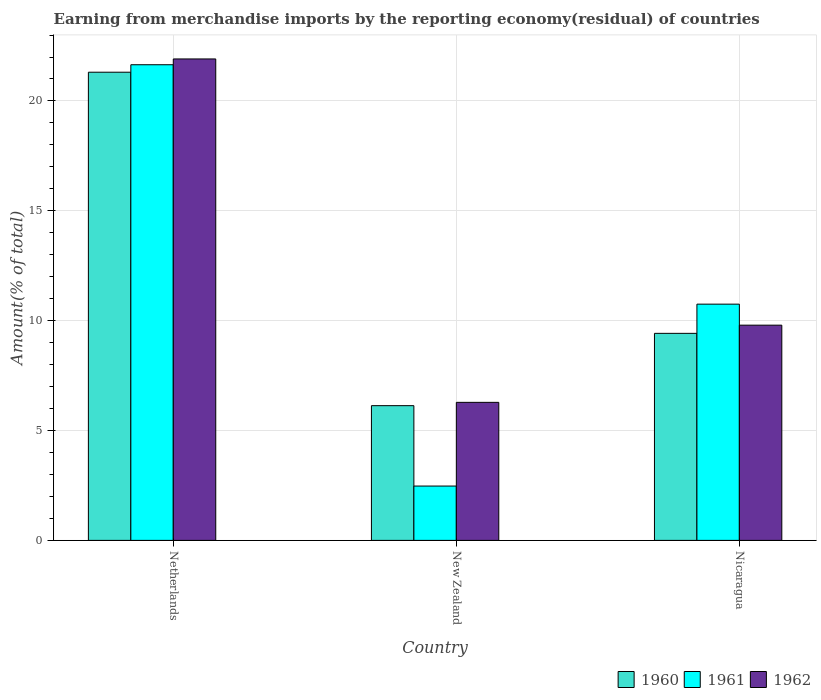How many different coloured bars are there?
Offer a very short reply. 3. How many groups of bars are there?
Your answer should be very brief. 3. Are the number of bars per tick equal to the number of legend labels?
Keep it short and to the point. Yes. What is the percentage of amount earned from merchandise imports in 1962 in Nicaragua?
Provide a short and direct response. 9.8. Across all countries, what is the maximum percentage of amount earned from merchandise imports in 1960?
Your answer should be very brief. 21.31. Across all countries, what is the minimum percentage of amount earned from merchandise imports in 1960?
Keep it short and to the point. 6.13. In which country was the percentage of amount earned from merchandise imports in 1962 maximum?
Your answer should be compact. Netherlands. In which country was the percentage of amount earned from merchandise imports in 1961 minimum?
Offer a terse response. New Zealand. What is the total percentage of amount earned from merchandise imports in 1961 in the graph?
Ensure brevity in your answer.  34.87. What is the difference between the percentage of amount earned from merchandise imports in 1962 in Netherlands and that in New Zealand?
Ensure brevity in your answer.  15.63. What is the difference between the percentage of amount earned from merchandise imports in 1962 in Netherlands and the percentage of amount earned from merchandise imports in 1960 in New Zealand?
Your response must be concise. 15.78. What is the average percentage of amount earned from merchandise imports in 1961 per country?
Provide a short and direct response. 11.62. What is the difference between the percentage of amount earned from merchandise imports of/in 1961 and percentage of amount earned from merchandise imports of/in 1960 in Netherlands?
Make the answer very short. 0.34. In how many countries, is the percentage of amount earned from merchandise imports in 1961 greater than 2 %?
Ensure brevity in your answer.  3. What is the ratio of the percentage of amount earned from merchandise imports in 1962 in Netherlands to that in Nicaragua?
Make the answer very short. 2.24. Is the difference between the percentage of amount earned from merchandise imports in 1961 in Netherlands and New Zealand greater than the difference between the percentage of amount earned from merchandise imports in 1960 in Netherlands and New Zealand?
Make the answer very short. Yes. What is the difference between the highest and the second highest percentage of amount earned from merchandise imports in 1962?
Make the answer very short. -12.12. What is the difference between the highest and the lowest percentage of amount earned from merchandise imports in 1961?
Make the answer very short. 19.18. In how many countries, is the percentage of amount earned from merchandise imports in 1962 greater than the average percentage of amount earned from merchandise imports in 1962 taken over all countries?
Ensure brevity in your answer.  1. Is it the case that in every country, the sum of the percentage of amount earned from merchandise imports in 1960 and percentage of amount earned from merchandise imports in 1962 is greater than the percentage of amount earned from merchandise imports in 1961?
Offer a terse response. Yes. How many bars are there?
Your response must be concise. 9. Does the graph contain any zero values?
Offer a very short reply. No. What is the title of the graph?
Provide a short and direct response. Earning from merchandise imports by the reporting economy(residual) of countries. What is the label or title of the X-axis?
Your answer should be very brief. Country. What is the label or title of the Y-axis?
Your answer should be compact. Amount(% of total). What is the Amount(% of total) in 1960 in Netherlands?
Provide a short and direct response. 21.31. What is the Amount(% of total) of 1961 in Netherlands?
Provide a succinct answer. 21.65. What is the Amount(% of total) of 1962 in Netherlands?
Your answer should be very brief. 21.91. What is the Amount(% of total) in 1960 in New Zealand?
Your response must be concise. 6.13. What is the Amount(% of total) in 1961 in New Zealand?
Ensure brevity in your answer.  2.47. What is the Amount(% of total) in 1962 in New Zealand?
Offer a very short reply. 6.28. What is the Amount(% of total) of 1960 in Nicaragua?
Your answer should be compact. 9.42. What is the Amount(% of total) in 1961 in Nicaragua?
Make the answer very short. 10.75. What is the Amount(% of total) of 1962 in Nicaragua?
Give a very brief answer. 9.8. Across all countries, what is the maximum Amount(% of total) of 1960?
Offer a very short reply. 21.31. Across all countries, what is the maximum Amount(% of total) in 1961?
Give a very brief answer. 21.65. Across all countries, what is the maximum Amount(% of total) in 1962?
Your answer should be compact. 21.91. Across all countries, what is the minimum Amount(% of total) of 1960?
Make the answer very short. 6.13. Across all countries, what is the minimum Amount(% of total) of 1961?
Give a very brief answer. 2.47. Across all countries, what is the minimum Amount(% of total) of 1962?
Make the answer very short. 6.28. What is the total Amount(% of total) of 1960 in the graph?
Ensure brevity in your answer.  36.86. What is the total Amount(% of total) in 1961 in the graph?
Your answer should be very brief. 34.87. What is the total Amount(% of total) of 1962 in the graph?
Provide a short and direct response. 37.99. What is the difference between the Amount(% of total) of 1960 in Netherlands and that in New Zealand?
Ensure brevity in your answer.  15.18. What is the difference between the Amount(% of total) in 1961 in Netherlands and that in New Zealand?
Your answer should be compact. 19.18. What is the difference between the Amount(% of total) of 1962 in Netherlands and that in New Zealand?
Keep it short and to the point. 15.63. What is the difference between the Amount(% of total) of 1960 in Netherlands and that in Nicaragua?
Your answer should be compact. 11.89. What is the difference between the Amount(% of total) in 1961 in Netherlands and that in Nicaragua?
Give a very brief answer. 10.9. What is the difference between the Amount(% of total) of 1962 in Netherlands and that in Nicaragua?
Give a very brief answer. 12.12. What is the difference between the Amount(% of total) in 1960 in New Zealand and that in Nicaragua?
Provide a succinct answer. -3.29. What is the difference between the Amount(% of total) of 1961 in New Zealand and that in Nicaragua?
Give a very brief answer. -8.28. What is the difference between the Amount(% of total) in 1962 in New Zealand and that in Nicaragua?
Provide a succinct answer. -3.51. What is the difference between the Amount(% of total) in 1960 in Netherlands and the Amount(% of total) in 1961 in New Zealand?
Your answer should be very brief. 18.84. What is the difference between the Amount(% of total) in 1960 in Netherlands and the Amount(% of total) in 1962 in New Zealand?
Give a very brief answer. 15.03. What is the difference between the Amount(% of total) of 1961 in Netherlands and the Amount(% of total) of 1962 in New Zealand?
Ensure brevity in your answer.  15.37. What is the difference between the Amount(% of total) of 1960 in Netherlands and the Amount(% of total) of 1961 in Nicaragua?
Give a very brief answer. 10.56. What is the difference between the Amount(% of total) of 1960 in Netherlands and the Amount(% of total) of 1962 in Nicaragua?
Give a very brief answer. 11.51. What is the difference between the Amount(% of total) of 1961 in Netherlands and the Amount(% of total) of 1962 in Nicaragua?
Provide a succinct answer. 11.85. What is the difference between the Amount(% of total) of 1960 in New Zealand and the Amount(% of total) of 1961 in Nicaragua?
Give a very brief answer. -4.62. What is the difference between the Amount(% of total) of 1960 in New Zealand and the Amount(% of total) of 1962 in Nicaragua?
Your response must be concise. -3.66. What is the difference between the Amount(% of total) of 1961 in New Zealand and the Amount(% of total) of 1962 in Nicaragua?
Offer a terse response. -7.32. What is the average Amount(% of total) of 1960 per country?
Give a very brief answer. 12.29. What is the average Amount(% of total) in 1961 per country?
Offer a very short reply. 11.62. What is the average Amount(% of total) in 1962 per country?
Provide a short and direct response. 12.66. What is the difference between the Amount(% of total) in 1960 and Amount(% of total) in 1961 in Netherlands?
Your answer should be compact. -0.34. What is the difference between the Amount(% of total) of 1960 and Amount(% of total) of 1962 in Netherlands?
Offer a terse response. -0.6. What is the difference between the Amount(% of total) in 1961 and Amount(% of total) in 1962 in Netherlands?
Keep it short and to the point. -0.26. What is the difference between the Amount(% of total) in 1960 and Amount(% of total) in 1961 in New Zealand?
Provide a succinct answer. 3.66. What is the difference between the Amount(% of total) in 1960 and Amount(% of total) in 1962 in New Zealand?
Offer a very short reply. -0.15. What is the difference between the Amount(% of total) of 1961 and Amount(% of total) of 1962 in New Zealand?
Ensure brevity in your answer.  -3.81. What is the difference between the Amount(% of total) of 1960 and Amount(% of total) of 1961 in Nicaragua?
Give a very brief answer. -1.33. What is the difference between the Amount(% of total) in 1960 and Amount(% of total) in 1962 in Nicaragua?
Your response must be concise. -0.37. What is the difference between the Amount(% of total) in 1961 and Amount(% of total) in 1962 in Nicaragua?
Provide a short and direct response. 0.96. What is the ratio of the Amount(% of total) in 1960 in Netherlands to that in New Zealand?
Provide a short and direct response. 3.48. What is the ratio of the Amount(% of total) in 1961 in Netherlands to that in New Zealand?
Ensure brevity in your answer.  8.76. What is the ratio of the Amount(% of total) of 1962 in Netherlands to that in New Zealand?
Ensure brevity in your answer.  3.49. What is the ratio of the Amount(% of total) of 1960 in Netherlands to that in Nicaragua?
Give a very brief answer. 2.26. What is the ratio of the Amount(% of total) in 1961 in Netherlands to that in Nicaragua?
Provide a succinct answer. 2.01. What is the ratio of the Amount(% of total) of 1962 in Netherlands to that in Nicaragua?
Your answer should be compact. 2.24. What is the ratio of the Amount(% of total) of 1960 in New Zealand to that in Nicaragua?
Your answer should be compact. 0.65. What is the ratio of the Amount(% of total) of 1961 in New Zealand to that in Nicaragua?
Give a very brief answer. 0.23. What is the ratio of the Amount(% of total) in 1962 in New Zealand to that in Nicaragua?
Provide a succinct answer. 0.64. What is the difference between the highest and the second highest Amount(% of total) of 1960?
Ensure brevity in your answer.  11.89. What is the difference between the highest and the second highest Amount(% of total) of 1961?
Give a very brief answer. 10.9. What is the difference between the highest and the second highest Amount(% of total) of 1962?
Give a very brief answer. 12.12. What is the difference between the highest and the lowest Amount(% of total) in 1960?
Your answer should be very brief. 15.18. What is the difference between the highest and the lowest Amount(% of total) of 1961?
Your response must be concise. 19.18. What is the difference between the highest and the lowest Amount(% of total) of 1962?
Your answer should be compact. 15.63. 